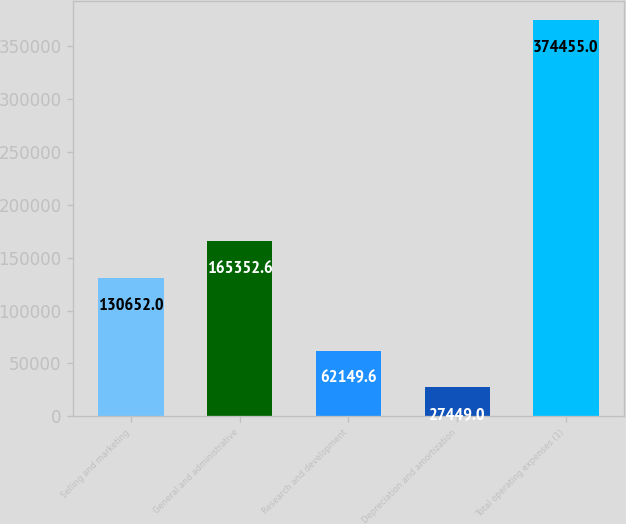Convert chart to OTSL. <chart><loc_0><loc_0><loc_500><loc_500><bar_chart><fcel>Selling and marketing<fcel>General and administrative<fcel>Research and development<fcel>Depreciation and amortization<fcel>Total operating expenses (1)<nl><fcel>130652<fcel>165353<fcel>62149.6<fcel>27449<fcel>374455<nl></chart> 